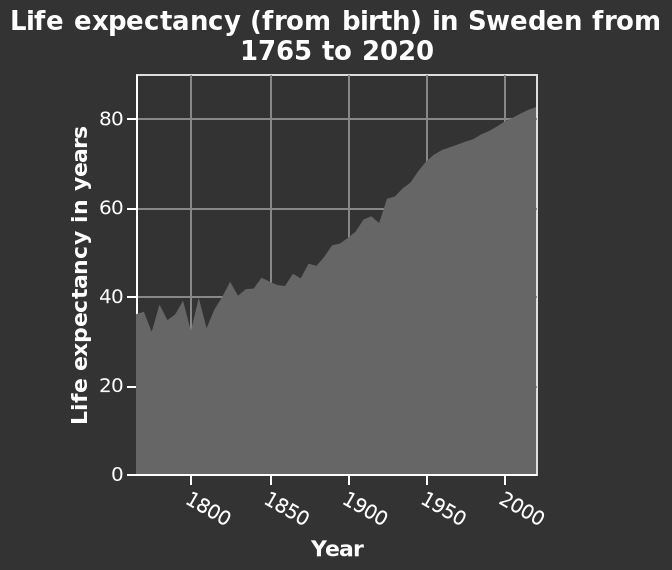<image>
What was the maximum life expectancy reached in 2020?  The maximum life expectancy reached in 2020 was around 83 years. What is the range of the x-axis scale? The x-axis scale ranges from 1800 to 2000, representing the years. 